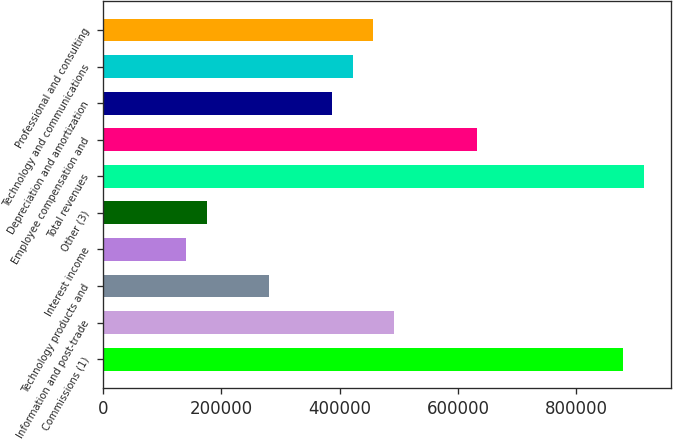Convert chart to OTSL. <chart><loc_0><loc_0><loc_500><loc_500><bar_chart><fcel>Commissions (1)<fcel>Information and post-trade<fcel>Technology products and<fcel>Interest income<fcel>Other (3)<fcel>Total revenues<fcel>Employee compensation and<fcel>Depreciation and amortization<fcel>Technology and communications<fcel>Professional and consulting<nl><fcel>878945<fcel>492209<fcel>281262<fcel>140631<fcel>175789<fcel>914102<fcel>632840<fcel>386736<fcel>421894<fcel>457051<nl></chart> 